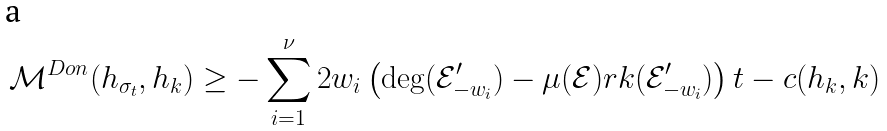Convert formula to latex. <formula><loc_0><loc_0><loc_500><loc_500>\mathcal { M } ^ { D o n } ( h _ { \sigma _ { t } } , h _ { k } ) \geq - \sum _ { i = 1 } ^ { \nu } 2 w _ { i } \left ( \deg ( \mathcal { E } ^ { \prime } _ { - w _ { i } } ) - \mu ( \mathcal { E } ) r k ( \mathcal { E } ^ { \prime } _ { - w _ { i } } ) \right ) t - c ( h _ { k } , k )</formula> 